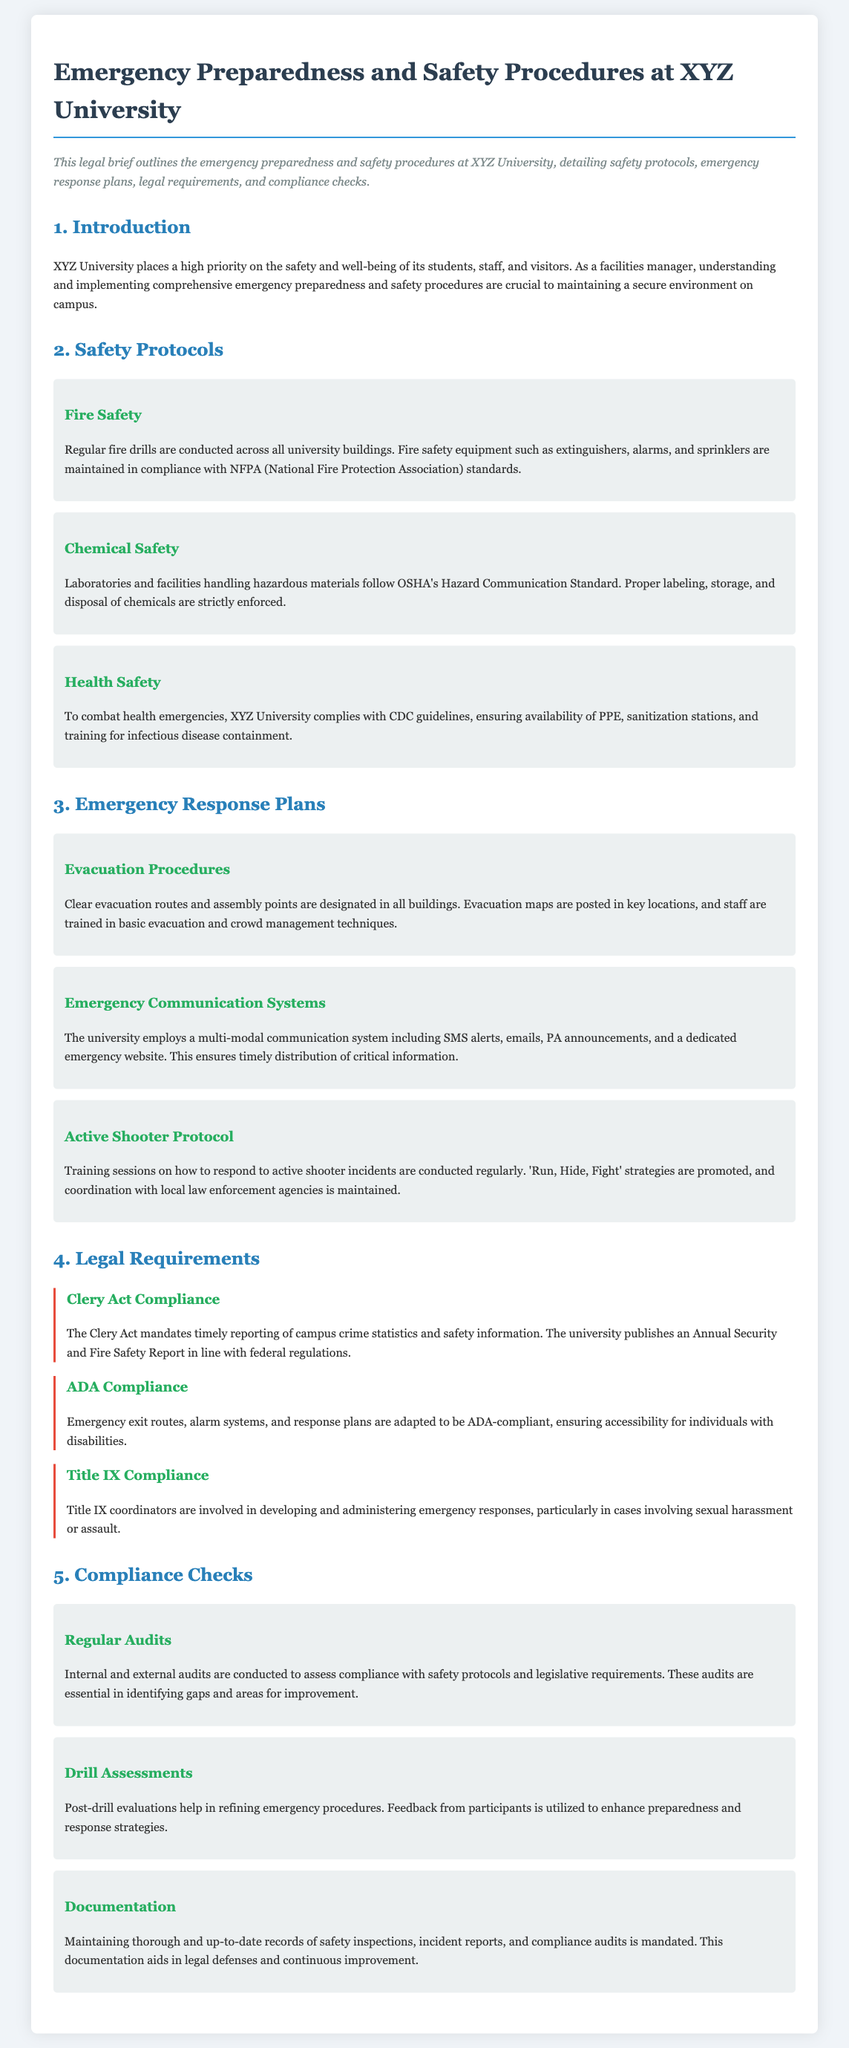What is the priority of XYZ University regarding safety? The priority of XYZ University is the safety and well-being of its students, staff, and visitors.
Answer: Safety and well-being How often are fire drills conducted at the university? The document states that regular fire drills are conducted across all university buildings.
Answer: Regularly Which standard governs chemical safety at XYZ University? Chemical safety is governed by OSHA's Hazard Communication Standard.
Answer: OSHA What strategy is promoted for responding to active shooter incidents? The strategy promoted is 'Run, Hide, Fight'.
Answer: Run, Hide, Fight What act mandates the reporting of campus crime statistics? The Clery Act mandates timely reporting of campus crime statistics.
Answer: Clery Act How are emergency exit routes and alarm systems adapted for compliance? They are adapted to be ADA-compliant.
Answer: ADA-compliant What type of assessments help refine emergency procedures? Post-drill evaluations help refine emergency procedures.
Answer: Post-drill evaluations How are audits used to ensure compliance? Audits are conducted to assess compliance with safety protocols and legislative requirements.
Answer: Assess compliance What is the role of Title IX coordinators in emergency responses? Title IX coordinators are involved in developing and administering emergency responses.
Answer: Involved in emergency responses 